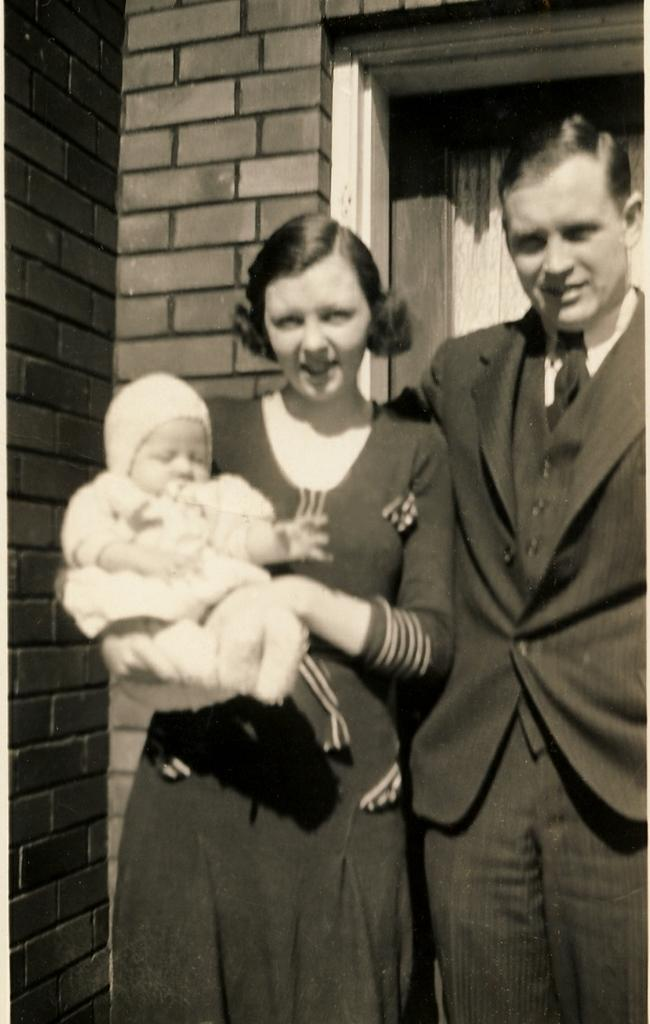How many people are in the image? There are 2 people standing in the image. What is the person on the left holding? The person on the left is carrying a baby. What can be seen in the background of the image? There is a brick wall building in the background. What features can be observed about the building? The building has a window and a curtain. What type of cheese is being served at the harmonious gathering in the image? There is no gathering or cheese present in the image. 